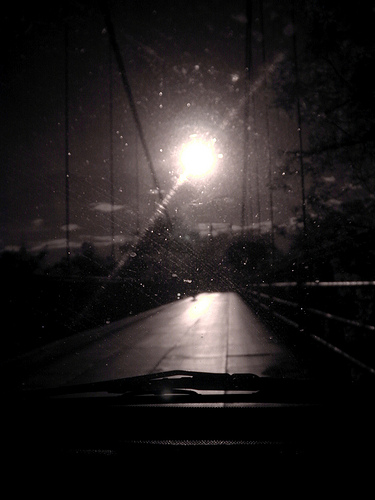<image>
Is the sun under the cable? No. The sun is not positioned under the cable. The vertical relationship between these objects is different. 